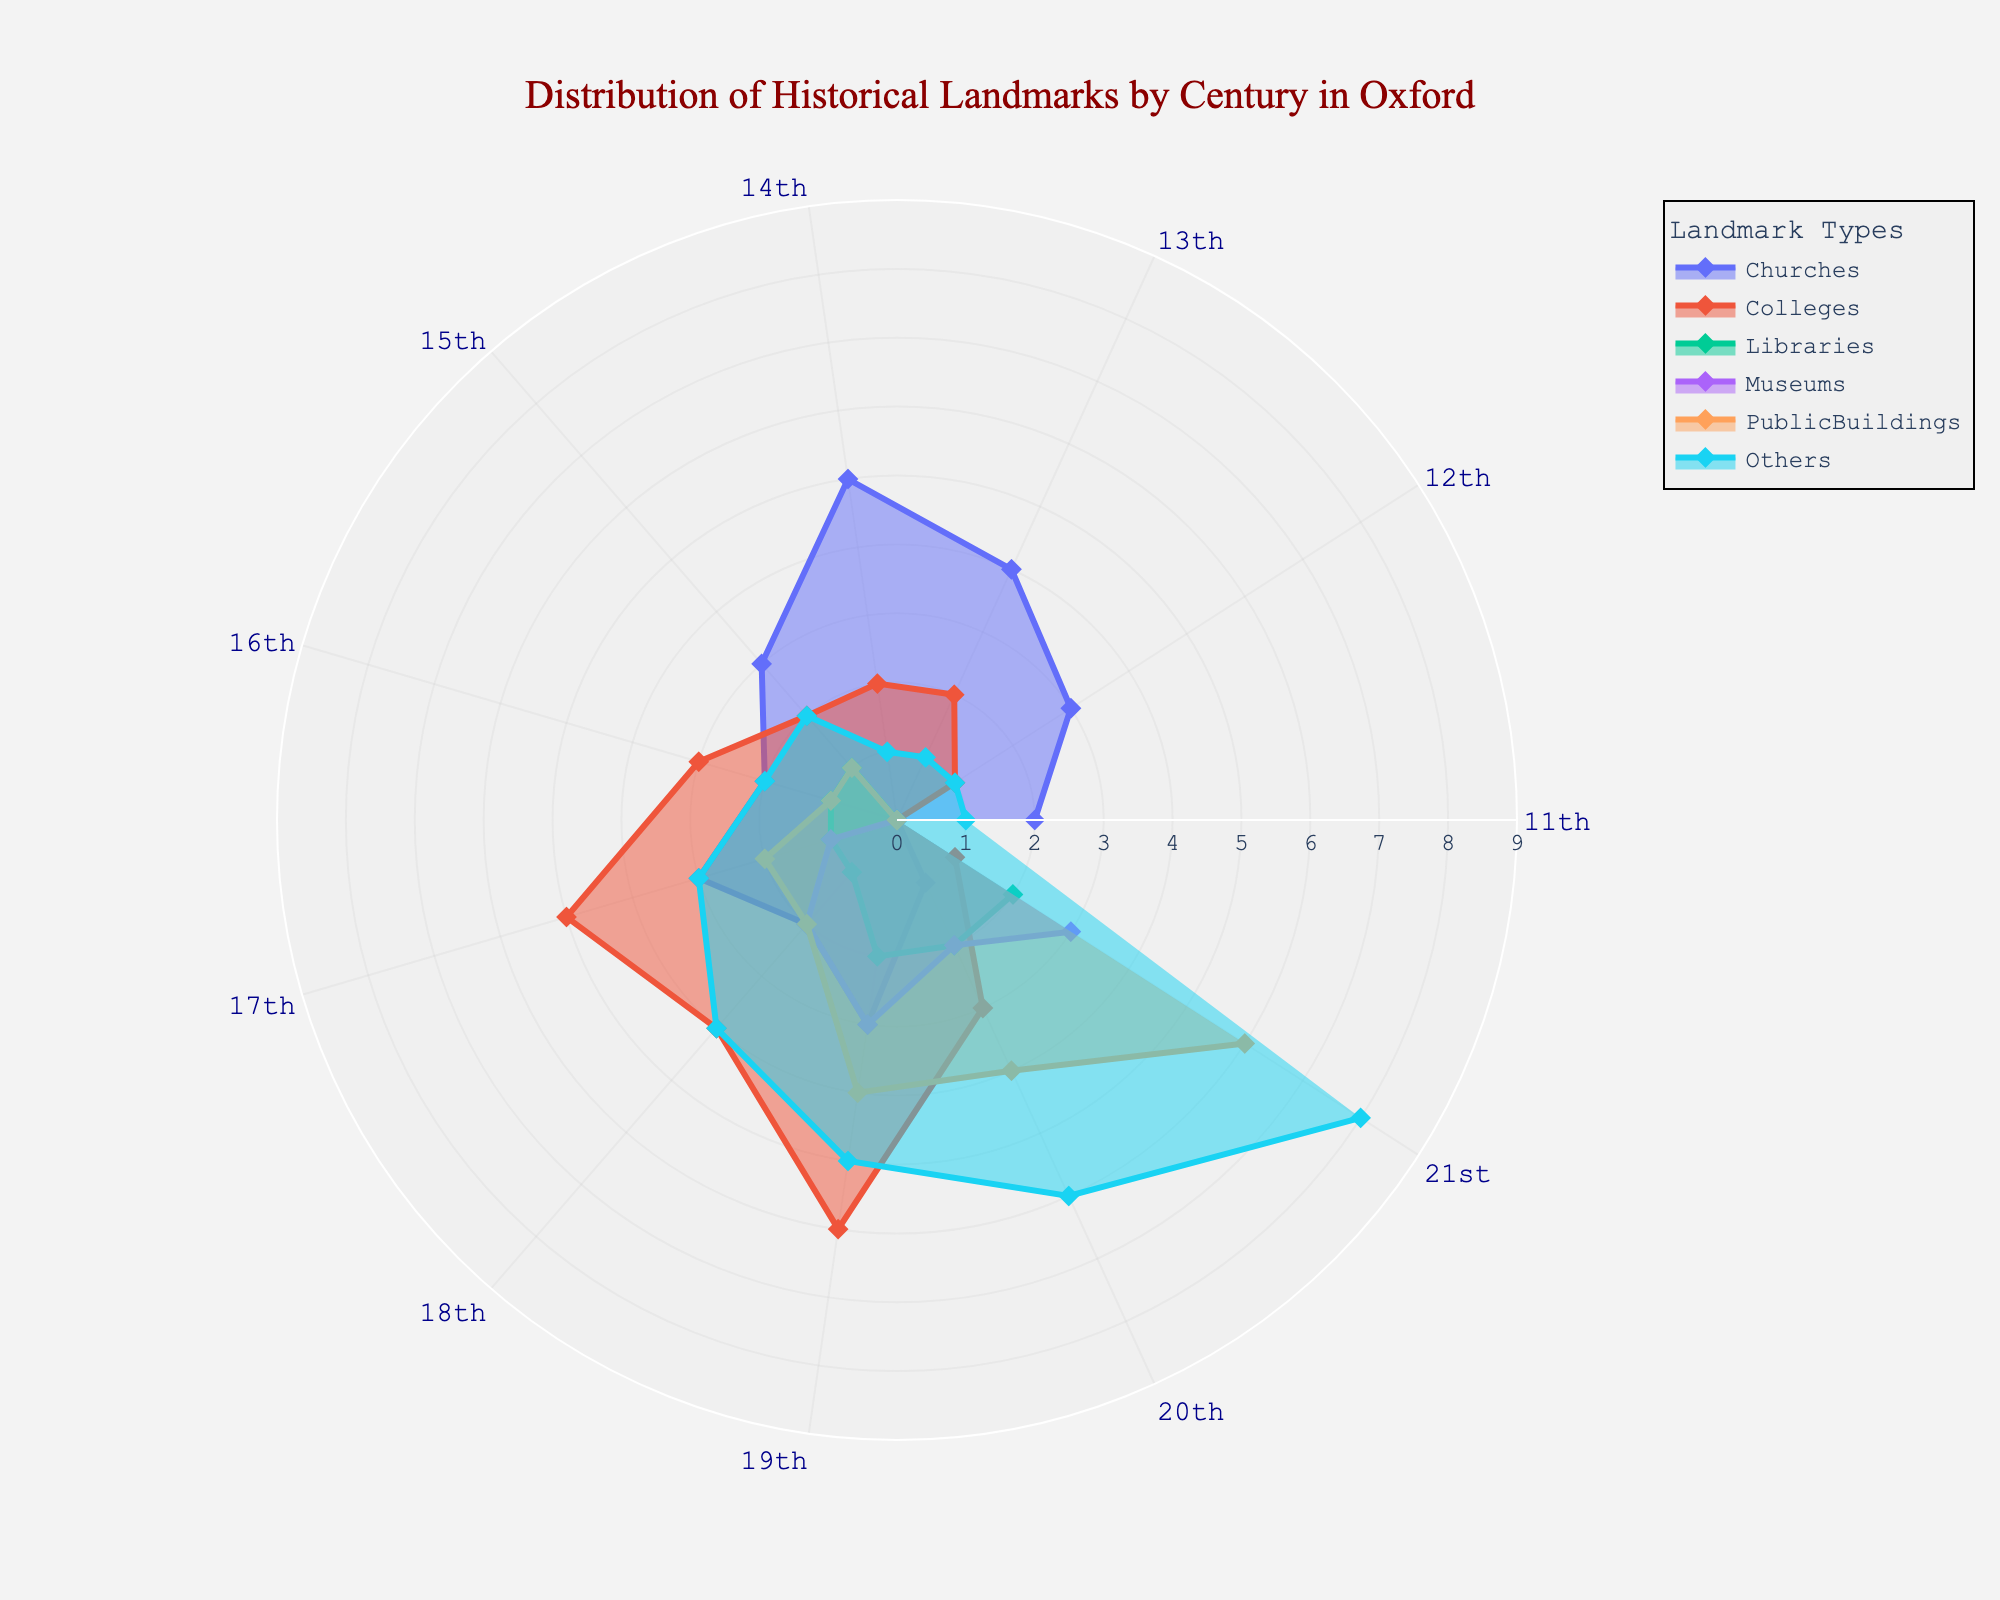What is the title of the figure? The title is usually placed at the top of the figure and is designed to provide an overview of what the figure represents.
Answer: Distribution of Historical Landmarks by Century in Oxford Which century has the highest number of museums? Looking at the data for museums in the radar chart, the 21st century has the highest count with 3 museums.
Answer: 21st century What type of landmark has the highest count in the 17th century? By observing the 17th-century data points, colleges have the highest count in this century with a value of 5.
Answer: Colleges How does the number of libraries in the 20th century compare to the number of libraries in the 21st century? The radar chart shows that the 20th century has 2 libraries and the 21st century also has 2, indicating they are equal.
Answer: Equal In which centuries do public buildings first appear, and how many are there in those centuries? Public buildings are first seen in the 15th century with 1 and in the 16th century with another 1.
Answer: 15th and 16th centuries, 1 each What is the total number of churches from the 11th to the 21st century? Add the number of churches from each century: 2 + 3 + 4 + 5 + 3 + 2 + 3 + 2 + 3 + 1 + 0 = 28 churches.
Answer: 28 churches Which category shows a consistent increase in numbers from the 11th to the 21st century? By looking at the trend lines, 'Others' show a consistent increase across all centuries, reaching a peak in the 21st century.
Answer: Others Compare the number of colleges between the 18th and 19th centuries; which century has more and by how many? The chart shows 4 colleges in the 18th century and 6 in the 19th century, so the 19th has 2 more colleges.
Answer: 19th century by 2 By how much does the count of public buildings increase from the 19th century to the 21st century? The radar chart shows 4 public buildings in the 19th century and 6 in the 21st century, indicating an increase of 2.
Answer: Increase by 2 Which century has the smallest number of churches and what is their count? From the radar chart, the 20th century has the smallest number with only 1 church.
Answer: 20th century, 1 church 